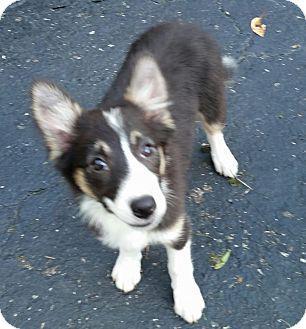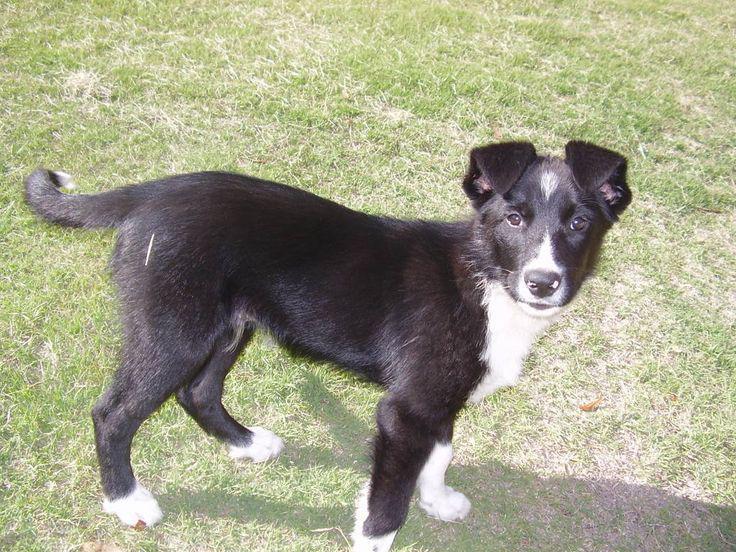The first image is the image on the left, the second image is the image on the right. Considering the images on both sides, is "Right image shows a dog standing on grass, with its body turned rightward." valid? Answer yes or no. Yes. The first image is the image on the left, the second image is the image on the right. Assess this claim about the two images: "In one of the images there is a dog standing in the grass and looking away from the camera.". Correct or not? Answer yes or no. No. 